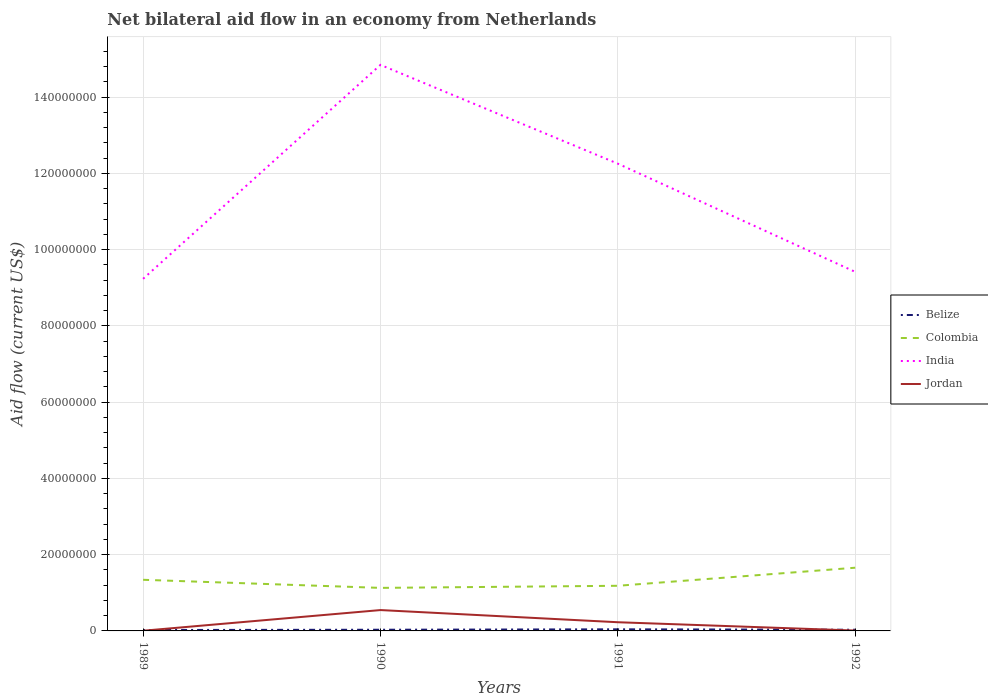Does the line corresponding to India intersect with the line corresponding to Colombia?
Keep it short and to the point. No. Is the number of lines equal to the number of legend labels?
Offer a very short reply. Yes. Across all years, what is the maximum net bilateral aid flow in Belize?
Make the answer very short. 2.40e+05. What is the total net bilateral aid flow in India in the graph?
Make the answer very short. 2.84e+07. What is the difference between the highest and the second highest net bilateral aid flow in Colombia?
Provide a short and direct response. 5.29e+06. Is the net bilateral aid flow in Belize strictly greater than the net bilateral aid flow in Jordan over the years?
Your answer should be very brief. No. How many lines are there?
Offer a very short reply. 4. How many years are there in the graph?
Ensure brevity in your answer.  4. Are the values on the major ticks of Y-axis written in scientific E-notation?
Keep it short and to the point. No. Does the graph contain any zero values?
Give a very brief answer. No. Does the graph contain grids?
Make the answer very short. Yes. Where does the legend appear in the graph?
Your response must be concise. Center right. How are the legend labels stacked?
Your answer should be compact. Vertical. What is the title of the graph?
Give a very brief answer. Net bilateral aid flow in an economy from Netherlands. Does "Guam" appear as one of the legend labels in the graph?
Offer a very short reply. No. What is the label or title of the Y-axis?
Your response must be concise. Aid flow (current US$). What is the Aid flow (current US$) in Belize in 1989?
Ensure brevity in your answer.  2.40e+05. What is the Aid flow (current US$) in Colombia in 1989?
Give a very brief answer. 1.34e+07. What is the Aid flow (current US$) in India in 1989?
Your response must be concise. 9.24e+07. What is the Aid flow (current US$) of Jordan in 1989?
Keep it short and to the point. 5.00e+04. What is the Aid flow (current US$) of Belize in 1990?
Provide a succinct answer. 3.10e+05. What is the Aid flow (current US$) in Colombia in 1990?
Your answer should be compact. 1.13e+07. What is the Aid flow (current US$) of India in 1990?
Ensure brevity in your answer.  1.48e+08. What is the Aid flow (current US$) of Jordan in 1990?
Your answer should be very brief. 5.47e+06. What is the Aid flow (current US$) in Colombia in 1991?
Your response must be concise. 1.18e+07. What is the Aid flow (current US$) in India in 1991?
Give a very brief answer. 1.23e+08. What is the Aid flow (current US$) in Jordan in 1991?
Keep it short and to the point. 2.28e+06. What is the Aid flow (current US$) in Colombia in 1992?
Keep it short and to the point. 1.66e+07. What is the Aid flow (current US$) of India in 1992?
Ensure brevity in your answer.  9.42e+07. Across all years, what is the maximum Aid flow (current US$) of Belize?
Offer a very short reply. 4.20e+05. Across all years, what is the maximum Aid flow (current US$) of Colombia?
Offer a terse response. 1.66e+07. Across all years, what is the maximum Aid flow (current US$) in India?
Provide a succinct answer. 1.48e+08. Across all years, what is the maximum Aid flow (current US$) in Jordan?
Provide a succinct answer. 5.47e+06. Across all years, what is the minimum Aid flow (current US$) of Colombia?
Your answer should be very brief. 1.13e+07. Across all years, what is the minimum Aid flow (current US$) in India?
Provide a succinct answer. 9.24e+07. Across all years, what is the minimum Aid flow (current US$) in Jordan?
Offer a terse response. 5.00e+04. What is the total Aid flow (current US$) in Belize in the graph?
Offer a very short reply. 1.28e+06. What is the total Aid flow (current US$) in Colombia in the graph?
Offer a terse response. 5.31e+07. What is the total Aid flow (current US$) of India in the graph?
Your response must be concise. 4.58e+08. What is the total Aid flow (current US$) in Jordan in the graph?
Give a very brief answer. 7.90e+06. What is the difference between the Aid flow (current US$) of Colombia in 1989 and that in 1990?
Your answer should be compact. 2.12e+06. What is the difference between the Aid flow (current US$) in India in 1989 and that in 1990?
Provide a short and direct response. -5.61e+07. What is the difference between the Aid flow (current US$) of Jordan in 1989 and that in 1990?
Provide a succinct answer. -5.42e+06. What is the difference between the Aid flow (current US$) of Colombia in 1989 and that in 1991?
Make the answer very short. 1.57e+06. What is the difference between the Aid flow (current US$) of India in 1989 and that in 1991?
Keep it short and to the point. -3.02e+07. What is the difference between the Aid flow (current US$) in Jordan in 1989 and that in 1991?
Offer a terse response. -2.23e+06. What is the difference between the Aid flow (current US$) of Belize in 1989 and that in 1992?
Your response must be concise. -7.00e+04. What is the difference between the Aid flow (current US$) of Colombia in 1989 and that in 1992?
Provide a short and direct response. -3.17e+06. What is the difference between the Aid flow (current US$) of India in 1989 and that in 1992?
Your answer should be compact. -1.82e+06. What is the difference between the Aid flow (current US$) of Jordan in 1989 and that in 1992?
Your answer should be compact. -5.00e+04. What is the difference between the Aid flow (current US$) in Colombia in 1990 and that in 1991?
Your answer should be compact. -5.50e+05. What is the difference between the Aid flow (current US$) in India in 1990 and that in 1991?
Your answer should be compact. 2.59e+07. What is the difference between the Aid flow (current US$) in Jordan in 1990 and that in 1991?
Your response must be concise. 3.19e+06. What is the difference between the Aid flow (current US$) in Belize in 1990 and that in 1992?
Ensure brevity in your answer.  0. What is the difference between the Aid flow (current US$) of Colombia in 1990 and that in 1992?
Give a very brief answer. -5.29e+06. What is the difference between the Aid flow (current US$) of India in 1990 and that in 1992?
Offer a very short reply. 5.43e+07. What is the difference between the Aid flow (current US$) in Jordan in 1990 and that in 1992?
Give a very brief answer. 5.37e+06. What is the difference between the Aid flow (current US$) in Belize in 1991 and that in 1992?
Provide a short and direct response. 1.10e+05. What is the difference between the Aid flow (current US$) in Colombia in 1991 and that in 1992?
Your answer should be very brief. -4.74e+06. What is the difference between the Aid flow (current US$) of India in 1991 and that in 1992?
Your response must be concise. 2.84e+07. What is the difference between the Aid flow (current US$) in Jordan in 1991 and that in 1992?
Ensure brevity in your answer.  2.18e+06. What is the difference between the Aid flow (current US$) of Belize in 1989 and the Aid flow (current US$) of Colombia in 1990?
Provide a short and direct response. -1.10e+07. What is the difference between the Aid flow (current US$) of Belize in 1989 and the Aid flow (current US$) of India in 1990?
Make the answer very short. -1.48e+08. What is the difference between the Aid flow (current US$) in Belize in 1989 and the Aid flow (current US$) in Jordan in 1990?
Give a very brief answer. -5.23e+06. What is the difference between the Aid flow (current US$) of Colombia in 1989 and the Aid flow (current US$) of India in 1990?
Provide a short and direct response. -1.35e+08. What is the difference between the Aid flow (current US$) in Colombia in 1989 and the Aid flow (current US$) in Jordan in 1990?
Keep it short and to the point. 7.94e+06. What is the difference between the Aid flow (current US$) in India in 1989 and the Aid flow (current US$) in Jordan in 1990?
Give a very brief answer. 8.69e+07. What is the difference between the Aid flow (current US$) in Belize in 1989 and the Aid flow (current US$) in Colombia in 1991?
Provide a succinct answer. -1.16e+07. What is the difference between the Aid flow (current US$) of Belize in 1989 and the Aid flow (current US$) of India in 1991?
Offer a very short reply. -1.22e+08. What is the difference between the Aid flow (current US$) in Belize in 1989 and the Aid flow (current US$) in Jordan in 1991?
Provide a succinct answer. -2.04e+06. What is the difference between the Aid flow (current US$) of Colombia in 1989 and the Aid flow (current US$) of India in 1991?
Keep it short and to the point. -1.09e+08. What is the difference between the Aid flow (current US$) in Colombia in 1989 and the Aid flow (current US$) in Jordan in 1991?
Provide a succinct answer. 1.11e+07. What is the difference between the Aid flow (current US$) of India in 1989 and the Aid flow (current US$) of Jordan in 1991?
Your response must be concise. 9.01e+07. What is the difference between the Aid flow (current US$) in Belize in 1989 and the Aid flow (current US$) in Colombia in 1992?
Your answer should be compact. -1.63e+07. What is the difference between the Aid flow (current US$) in Belize in 1989 and the Aid flow (current US$) in India in 1992?
Your answer should be very brief. -9.39e+07. What is the difference between the Aid flow (current US$) in Belize in 1989 and the Aid flow (current US$) in Jordan in 1992?
Keep it short and to the point. 1.40e+05. What is the difference between the Aid flow (current US$) of Colombia in 1989 and the Aid flow (current US$) of India in 1992?
Keep it short and to the point. -8.08e+07. What is the difference between the Aid flow (current US$) of Colombia in 1989 and the Aid flow (current US$) of Jordan in 1992?
Offer a terse response. 1.33e+07. What is the difference between the Aid flow (current US$) in India in 1989 and the Aid flow (current US$) in Jordan in 1992?
Keep it short and to the point. 9.23e+07. What is the difference between the Aid flow (current US$) in Belize in 1990 and the Aid flow (current US$) in Colombia in 1991?
Your response must be concise. -1.15e+07. What is the difference between the Aid flow (current US$) in Belize in 1990 and the Aid flow (current US$) in India in 1991?
Your response must be concise. -1.22e+08. What is the difference between the Aid flow (current US$) of Belize in 1990 and the Aid flow (current US$) of Jordan in 1991?
Make the answer very short. -1.97e+06. What is the difference between the Aid flow (current US$) in Colombia in 1990 and the Aid flow (current US$) in India in 1991?
Give a very brief answer. -1.11e+08. What is the difference between the Aid flow (current US$) of Colombia in 1990 and the Aid flow (current US$) of Jordan in 1991?
Offer a very short reply. 9.01e+06. What is the difference between the Aid flow (current US$) of India in 1990 and the Aid flow (current US$) of Jordan in 1991?
Ensure brevity in your answer.  1.46e+08. What is the difference between the Aid flow (current US$) in Belize in 1990 and the Aid flow (current US$) in Colombia in 1992?
Your answer should be compact. -1.63e+07. What is the difference between the Aid flow (current US$) in Belize in 1990 and the Aid flow (current US$) in India in 1992?
Ensure brevity in your answer.  -9.39e+07. What is the difference between the Aid flow (current US$) of Belize in 1990 and the Aid flow (current US$) of Jordan in 1992?
Your answer should be compact. 2.10e+05. What is the difference between the Aid flow (current US$) in Colombia in 1990 and the Aid flow (current US$) in India in 1992?
Your response must be concise. -8.29e+07. What is the difference between the Aid flow (current US$) of Colombia in 1990 and the Aid flow (current US$) of Jordan in 1992?
Offer a terse response. 1.12e+07. What is the difference between the Aid flow (current US$) in India in 1990 and the Aid flow (current US$) in Jordan in 1992?
Provide a short and direct response. 1.48e+08. What is the difference between the Aid flow (current US$) of Belize in 1991 and the Aid flow (current US$) of Colombia in 1992?
Provide a succinct answer. -1.62e+07. What is the difference between the Aid flow (current US$) in Belize in 1991 and the Aid flow (current US$) in India in 1992?
Make the answer very short. -9.38e+07. What is the difference between the Aid flow (current US$) of Belize in 1991 and the Aid flow (current US$) of Jordan in 1992?
Your answer should be very brief. 3.20e+05. What is the difference between the Aid flow (current US$) in Colombia in 1991 and the Aid flow (current US$) in India in 1992?
Offer a very short reply. -8.23e+07. What is the difference between the Aid flow (current US$) in Colombia in 1991 and the Aid flow (current US$) in Jordan in 1992?
Your answer should be compact. 1.17e+07. What is the difference between the Aid flow (current US$) in India in 1991 and the Aid flow (current US$) in Jordan in 1992?
Your answer should be very brief. 1.22e+08. What is the average Aid flow (current US$) of Belize per year?
Give a very brief answer. 3.20e+05. What is the average Aid flow (current US$) of Colombia per year?
Keep it short and to the point. 1.33e+07. What is the average Aid flow (current US$) of India per year?
Make the answer very short. 1.14e+08. What is the average Aid flow (current US$) in Jordan per year?
Provide a succinct answer. 1.98e+06. In the year 1989, what is the difference between the Aid flow (current US$) of Belize and Aid flow (current US$) of Colombia?
Make the answer very short. -1.32e+07. In the year 1989, what is the difference between the Aid flow (current US$) in Belize and Aid flow (current US$) in India?
Give a very brief answer. -9.21e+07. In the year 1989, what is the difference between the Aid flow (current US$) of Colombia and Aid flow (current US$) of India?
Provide a short and direct response. -7.90e+07. In the year 1989, what is the difference between the Aid flow (current US$) in Colombia and Aid flow (current US$) in Jordan?
Provide a short and direct response. 1.34e+07. In the year 1989, what is the difference between the Aid flow (current US$) in India and Aid flow (current US$) in Jordan?
Provide a short and direct response. 9.23e+07. In the year 1990, what is the difference between the Aid flow (current US$) in Belize and Aid flow (current US$) in Colombia?
Provide a short and direct response. -1.10e+07. In the year 1990, what is the difference between the Aid flow (current US$) in Belize and Aid flow (current US$) in India?
Your response must be concise. -1.48e+08. In the year 1990, what is the difference between the Aid flow (current US$) of Belize and Aid flow (current US$) of Jordan?
Provide a succinct answer. -5.16e+06. In the year 1990, what is the difference between the Aid flow (current US$) of Colombia and Aid flow (current US$) of India?
Your response must be concise. -1.37e+08. In the year 1990, what is the difference between the Aid flow (current US$) in Colombia and Aid flow (current US$) in Jordan?
Give a very brief answer. 5.82e+06. In the year 1990, what is the difference between the Aid flow (current US$) of India and Aid flow (current US$) of Jordan?
Provide a short and direct response. 1.43e+08. In the year 1991, what is the difference between the Aid flow (current US$) in Belize and Aid flow (current US$) in Colombia?
Ensure brevity in your answer.  -1.14e+07. In the year 1991, what is the difference between the Aid flow (current US$) of Belize and Aid flow (current US$) of India?
Provide a short and direct response. -1.22e+08. In the year 1991, what is the difference between the Aid flow (current US$) in Belize and Aid flow (current US$) in Jordan?
Provide a short and direct response. -1.86e+06. In the year 1991, what is the difference between the Aid flow (current US$) in Colombia and Aid flow (current US$) in India?
Give a very brief answer. -1.11e+08. In the year 1991, what is the difference between the Aid flow (current US$) in Colombia and Aid flow (current US$) in Jordan?
Your answer should be compact. 9.56e+06. In the year 1991, what is the difference between the Aid flow (current US$) of India and Aid flow (current US$) of Jordan?
Provide a short and direct response. 1.20e+08. In the year 1992, what is the difference between the Aid flow (current US$) of Belize and Aid flow (current US$) of Colombia?
Your answer should be very brief. -1.63e+07. In the year 1992, what is the difference between the Aid flow (current US$) of Belize and Aid flow (current US$) of India?
Your answer should be very brief. -9.39e+07. In the year 1992, what is the difference between the Aid flow (current US$) in Belize and Aid flow (current US$) in Jordan?
Your response must be concise. 2.10e+05. In the year 1992, what is the difference between the Aid flow (current US$) of Colombia and Aid flow (current US$) of India?
Ensure brevity in your answer.  -7.76e+07. In the year 1992, what is the difference between the Aid flow (current US$) of Colombia and Aid flow (current US$) of Jordan?
Provide a short and direct response. 1.65e+07. In the year 1992, what is the difference between the Aid flow (current US$) in India and Aid flow (current US$) in Jordan?
Keep it short and to the point. 9.41e+07. What is the ratio of the Aid flow (current US$) of Belize in 1989 to that in 1990?
Your answer should be very brief. 0.77. What is the ratio of the Aid flow (current US$) in Colombia in 1989 to that in 1990?
Make the answer very short. 1.19. What is the ratio of the Aid flow (current US$) of India in 1989 to that in 1990?
Keep it short and to the point. 0.62. What is the ratio of the Aid flow (current US$) in Jordan in 1989 to that in 1990?
Offer a very short reply. 0.01. What is the ratio of the Aid flow (current US$) of Colombia in 1989 to that in 1991?
Your answer should be compact. 1.13. What is the ratio of the Aid flow (current US$) of India in 1989 to that in 1991?
Your response must be concise. 0.75. What is the ratio of the Aid flow (current US$) in Jordan in 1989 to that in 1991?
Your response must be concise. 0.02. What is the ratio of the Aid flow (current US$) of Belize in 1989 to that in 1992?
Provide a short and direct response. 0.77. What is the ratio of the Aid flow (current US$) of Colombia in 1989 to that in 1992?
Ensure brevity in your answer.  0.81. What is the ratio of the Aid flow (current US$) of India in 1989 to that in 1992?
Provide a succinct answer. 0.98. What is the ratio of the Aid flow (current US$) of Jordan in 1989 to that in 1992?
Your response must be concise. 0.5. What is the ratio of the Aid flow (current US$) of Belize in 1990 to that in 1991?
Give a very brief answer. 0.74. What is the ratio of the Aid flow (current US$) in Colombia in 1990 to that in 1991?
Offer a very short reply. 0.95. What is the ratio of the Aid flow (current US$) of India in 1990 to that in 1991?
Offer a terse response. 1.21. What is the ratio of the Aid flow (current US$) of Jordan in 1990 to that in 1991?
Your answer should be very brief. 2.4. What is the ratio of the Aid flow (current US$) of Colombia in 1990 to that in 1992?
Make the answer very short. 0.68. What is the ratio of the Aid flow (current US$) of India in 1990 to that in 1992?
Provide a succinct answer. 1.58. What is the ratio of the Aid flow (current US$) in Jordan in 1990 to that in 1992?
Keep it short and to the point. 54.7. What is the ratio of the Aid flow (current US$) in Belize in 1991 to that in 1992?
Keep it short and to the point. 1.35. What is the ratio of the Aid flow (current US$) in Colombia in 1991 to that in 1992?
Offer a very short reply. 0.71. What is the ratio of the Aid flow (current US$) of India in 1991 to that in 1992?
Give a very brief answer. 1.3. What is the ratio of the Aid flow (current US$) in Jordan in 1991 to that in 1992?
Ensure brevity in your answer.  22.8. What is the difference between the highest and the second highest Aid flow (current US$) in Belize?
Your answer should be compact. 1.10e+05. What is the difference between the highest and the second highest Aid flow (current US$) in Colombia?
Provide a short and direct response. 3.17e+06. What is the difference between the highest and the second highest Aid flow (current US$) in India?
Your response must be concise. 2.59e+07. What is the difference between the highest and the second highest Aid flow (current US$) in Jordan?
Provide a succinct answer. 3.19e+06. What is the difference between the highest and the lowest Aid flow (current US$) in Belize?
Offer a terse response. 1.80e+05. What is the difference between the highest and the lowest Aid flow (current US$) of Colombia?
Ensure brevity in your answer.  5.29e+06. What is the difference between the highest and the lowest Aid flow (current US$) in India?
Provide a short and direct response. 5.61e+07. What is the difference between the highest and the lowest Aid flow (current US$) of Jordan?
Give a very brief answer. 5.42e+06. 